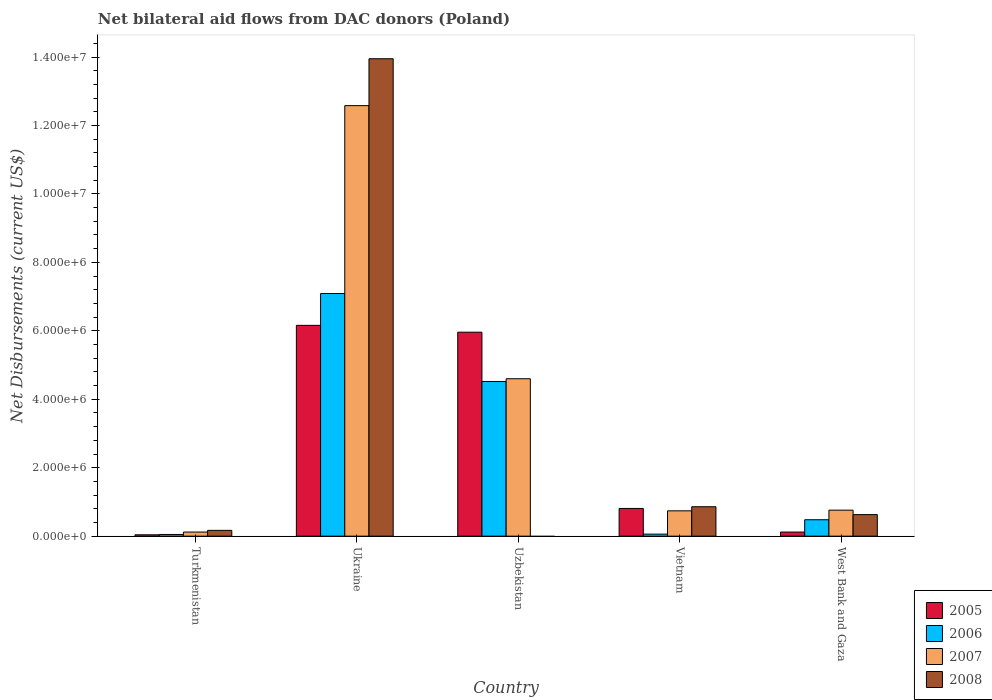How many groups of bars are there?
Your answer should be compact. 5. How many bars are there on the 4th tick from the left?
Offer a terse response. 4. What is the label of the 5th group of bars from the left?
Your response must be concise. West Bank and Gaza. What is the net bilateral aid flows in 2005 in Ukraine?
Provide a short and direct response. 6.16e+06. Across all countries, what is the maximum net bilateral aid flows in 2005?
Your answer should be compact. 6.16e+06. In which country was the net bilateral aid flows in 2006 maximum?
Ensure brevity in your answer.  Ukraine. What is the total net bilateral aid flows in 2008 in the graph?
Your response must be concise. 1.56e+07. What is the difference between the net bilateral aid flows in 2005 in Uzbekistan and that in West Bank and Gaza?
Your response must be concise. 5.84e+06. What is the difference between the net bilateral aid flows in 2008 in West Bank and Gaza and the net bilateral aid flows in 2006 in Turkmenistan?
Ensure brevity in your answer.  5.80e+05. What is the average net bilateral aid flows in 2008 per country?
Provide a succinct answer. 3.12e+06. What is the difference between the net bilateral aid flows of/in 2006 and net bilateral aid flows of/in 2005 in Uzbekistan?
Your answer should be very brief. -1.44e+06. What is the ratio of the net bilateral aid flows in 2005 in Ukraine to that in Uzbekistan?
Offer a terse response. 1.03. Is the difference between the net bilateral aid flows in 2006 in Ukraine and Vietnam greater than the difference between the net bilateral aid flows in 2005 in Ukraine and Vietnam?
Provide a short and direct response. Yes. What is the difference between the highest and the second highest net bilateral aid flows in 2008?
Ensure brevity in your answer.  1.31e+07. What is the difference between the highest and the lowest net bilateral aid flows in 2005?
Keep it short and to the point. 6.12e+06. In how many countries, is the net bilateral aid flows in 2005 greater than the average net bilateral aid flows in 2005 taken over all countries?
Provide a succinct answer. 2. How many bars are there?
Your answer should be very brief. 19. What is the difference between two consecutive major ticks on the Y-axis?
Make the answer very short. 2.00e+06. How are the legend labels stacked?
Your response must be concise. Vertical. What is the title of the graph?
Ensure brevity in your answer.  Net bilateral aid flows from DAC donors (Poland). What is the label or title of the Y-axis?
Offer a very short reply. Net Disbursements (current US$). What is the Net Disbursements (current US$) of 2005 in Turkmenistan?
Offer a terse response. 4.00e+04. What is the Net Disbursements (current US$) of 2006 in Turkmenistan?
Your answer should be very brief. 5.00e+04. What is the Net Disbursements (current US$) in 2007 in Turkmenistan?
Your answer should be compact. 1.20e+05. What is the Net Disbursements (current US$) in 2008 in Turkmenistan?
Offer a very short reply. 1.70e+05. What is the Net Disbursements (current US$) in 2005 in Ukraine?
Provide a succinct answer. 6.16e+06. What is the Net Disbursements (current US$) of 2006 in Ukraine?
Make the answer very short. 7.09e+06. What is the Net Disbursements (current US$) in 2007 in Ukraine?
Make the answer very short. 1.26e+07. What is the Net Disbursements (current US$) of 2008 in Ukraine?
Provide a succinct answer. 1.40e+07. What is the Net Disbursements (current US$) in 2005 in Uzbekistan?
Your answer should be compact. 5.96e+06. What is the Net Disbursements (current US$) in 2006 in Uzbekistan?
Provide a succinct answer. 4.52e+06. What is the Net Disbursements (current US$) in 2007 in Uzbekistan?
Your answer should be compact. 4.60e+06. What is the Net Disbursements (current US$) in 2005 in Vietnam?
Your response must be concise. 8.10e+05. What is the Net Disbursements (current US$) of 2007 in Vietnam?
Give a very brief answer. 7.40e+05. What is the Net Disbursements (current US$) of 2008 in Vietnam?
Provide a succinct answer. 8.60e+05. What is the Net Disbursements (current US$) in 2007 in West Bank and Gaza?
Offer a terse response. 7.60e+05. What is the Net Disbursements (current US$) of 2008 in West Bank and Gaza?
Your response must be concise. 6.30e+05. Across all countries, what is the maximum Net Disbursements (current US$) of 2005?
Give a very brief answer. 6.16e+06. Across all countries, what is the maximum Net Disbursements (current US$) of 2006?
Make the answer very short. 7.09e+06. Across all countries, what is the maximum Net Disbursements (current US$) in 2007?
Your answer should be very brief. 1.26e+07. Across all countries, what is the maximum Net Disbursements (current US$) in 2008?
Make the answer very short. 1.40e+07. Across all countries, what is the minimum Net Disbursements (current US$) of 2005?
Offer a very short reply. 4.00e+04. Across all countries, what is the minimum Net Disbursements (current US$) of 2006?
Provide a succinct answer. 5.00e+04. Across all countries, what is the minimum Net Disbursements (current US$) in 2007?
Offer a terse response. 1.20e+05. Across all countries, what is the minimum Net Disbursements (current US$) in 2008?
Your response must be concise. 0. What is the total Net Disbursements (current US$) in 2005 in the graph?
Ensure brevity in your answer.  1.31e+07. What is the total Net Disbursements (current US$) of 2006 in the graph?
Offer a terse response. 1.22e+07. What is the total Net Disbursements (current US$) in 2007 in the graph?
Your answer should be compact. 1.88e+07. What is the total Net Disbursements (current US$) in 2008 in the graph?
Your answer should be very brief. 1.56e+07. What is the difference between the Net Disbursements (current US$) in 2005 in Turkmenistan and that in Ukraine?
Give a very brief answer. -6.12e+06. What is the difference between the Net Disbursements (current US$) in 2006 in Turkmenistan and that in Ukraine?
Offer a terse response. -7.04e+06. What is the difference between the Net Disbursements (current US$) of 2007 in Turkmenistan and that in Ukraine?
Offer a very short reply. -1.25e+07. What is the difference between the Net Disbursements (current US$) in 2008 in Turkmenistan and that in Ukraine?
Ensure brevity in your answer.  -1.38e+07. What is the difference between the Net Disbursements (current US$) in 2005 in Turkmenistan and that in Uzbekistan?
Provide a short and direct response. -5.92e+06. What is the difference between the Net Disbursements (current US$) in 2006 in Turkmenistan and that in Uzbekistan?
Offer a terse response. -4.47e+06. What is the difference between the Net Disbursements (current US$) of 2007 in Turkmenistan and that in Uzbekistan?
Ensure brevity in your answer.  -4.48e+06. What is the difference between the Net Disbursements (current US$) of 2005 in Turkmenistan and that in Vietnam?
Offer a terse response. -7.70e+05. What is the difference between the Net Disbursements (current US$) of 2007 in Turkmenistan and that in Vietnam?
Provide a short and direct response. -6.20e+05. What is the difference between the Net Disbursements (current US$) of 2008 in Turkmenistan and that in Vietnam?
Give a very brief answer. -6.90e+05. What is the difference between the Net Disbursements (current US$) of 2006 in Turkmenistan and that in West Bank and Gaza?
Keep it short and to the point. -4.30e+05. What is the difference between the Net Disbursements (current US$) of 2007 in Turkmenistan and that in West Bank and Gaza?
Your answer should be compact. -6.40e+05. What is the difference between the Net Disbursements (current US$) of 2008 in Turkmenistan and that in West Bank and Gaza?
Your response must be concise. -4.60e+05. What is the difference between the Net Disbursements (current US$) in 2006 in Ukraine and that in Uzbekistan?
Give a very brief answer. 2.57e+06. What is the difference between the Net Disbursements (current US$) in 2007 in Ukraine and that in Uzbekistan?
Keep it short and to the point. 7.98e+06. What is the difference between the Net Disbursements (current US$) in 2005 in Ukraine and that in Vietnam?
Provide a short and direct response. 5.35e+06. What is the difference between the Net Disbursements (current US$) in 2006 in Ukraine and that in Vietnam?
Your answer should be compact. 7.03e+06. What is the difference between the Net Disbursements (current US$) in 2007 in Ukraine and that in Vietnam?
Give a very brief answer. 1.18e+07. What is the difference between the Net Disbursements (current US$) of 2008 in Ukraine and that in Vietnam?
Provide a short and direct response. 1.31e+07. What is the difference between the Net Disbursements (current US$) of 2005 in Ukraine and that in West Bank and Gaza?
Keep it short and to the point. 6.04e+06. What is the difference between the Net Disbursements (current US$) of 2006 in Ukraine and that in West Bank and Gaza?
Give a very brief answer. 6.61e+06. What is the difference between the Net Disbursements (current US$) of 2007 in Ukraine and that in West Bank and Gaza?
Offer a very short reply. 1.18e+07. What is the difference between the Net Disbursements (current US$) in 2008 in Ukraine and that in West Bank and Gaza?
Ensure brevity in your answer.  1.33e+07. What is the difference between the Net Disbursements (current US$) of 2005 in Uzbekistan and that in Vietnam?
Provide a succinct answer. 5.15e+06. What is the difference between the Net Disbursements (current US$) of 2006 in Uzbekistan and that in Vietnam?
Provide a short and direct response. 4.46e+06. What is the difference between the Net Disbursements (current US$) of 2007 in Uzbekistan and that in Vietnam?
Make the answer very short. 3.86e+06. What is the difference between the Net Disbursements (current US$) in 2005 in Uzbekistan and that in West Bank and Gaza?
Give a very brief answer. 5.84e+06. What is the difference between the Net Disbursements (current US$) in 2006 in Uzbekistan and that in West Bank and Gaza?
Make the answer very short. 4.04e+06. What is the difference between the Net Disbursements (current US$) in 2007 in Uzbekistan and that in West Bank and Gaza?
Offer a terse response. 3.84e+06. What is the difference between the Net Disbursements (current US$) of 2005 in Vietnam and that in West Bank and Gaza?
Ensure brevity in your answer.  6.90e+05. What is the difference between the Net Disbursements (current US$) in 2006 in Vietnam and that in West Bank and Gaza?
Provide a short and direct response. -4.20e+05. What is the difference between the Net Disbursements (current US$) of 2007 in Vietnam and that in West Bank and Gaza?
Your answer should be compact. -2.00e+04. What is the difference between the Net Disbursements (current US$) of 2008 in Vietnam and that in West Bank and Gaza?
Your answer should be very brief. 2.30e+05. What is the difference between the Net Disbursements (current US$) in 2005 in Turkmenistan and the Net Disbursements (current US$) in 2006 in Ukraine?
Your response must be concise. -7.05e+06. What is the difference between the Net Disbursements (current US$) in 2005 in Turkmenistan and the Net Disbursements (current US$) in 2007 in Ukraine?
Keep it short and to the point. -1.25e+07. What is the difference between the Net Disbursements (current US$) of 2005 in Turkmenistan and the Net Disbursements (current US$) of 2008 in Ukraine?
Offer a terse response. -1.39e+07. What is the difference between the Net Disbursements (current US$) of 2006 in Turkmenistan and the Net Disbursements (current US$) of 2007 in Ukraine?
Provide a succinct answer. -1.25e+07. What is the difference between the Net Disbursements (current US$) in 2006 in Turkmenistan and the Net Disbursements (current US$) in 2008 in Ukraine?
Offer a very short reply. -1.39e+07. What is the difference between the Net Disbursements (current US$) in 2007 in Turkmenistan and the Net Disbursements (current US$) in 2008 in Ukraine?
Ensure brevity in your answer.  -1.38e+07. What is the difference between the Net Disbursements (current US$) in 2005 in Turkmenistan and the Net Disbursements (current US$) in 2006 in Uzbekistan?
Make the answer very short. -4.48e+06. What is the difference between the Net Disbursements (current US$) in 2005 in Turkmenistan and the Net Disbursements (current US$) in 2007 in Uzbekistan?
Your answer should be compact. -4.56e+06. What is the difference between the Net Disbursements (current US$) in 2006 in Turkmenistan and the Net Disbursements (current US$) in 2007 in Uzbekistan?
Provide a short and direct response. -4.55e+06. What is the difference between the Net Disbursements (current US$) in 2005 in Turkmenistan and the Net Disbursements (current US$) in 2006 in Vietnam?
Give a very brief answer. -2.00e+04. What is the difference between the Net Disbursements (current US$) in 2005 in Turkmenistan and the Net Disbursements (current US$) in 2007 in Vietnam?
Your answer should be very brief. -7.00e+05. What is the difference between the Net Disbursements (current US$) of 2005 in Turkmenistan and the Net Disbursements (current US$) of 2008 in Vietnam?
Offer a terse response. -8.20e+05. What is the difference between the Net Disbursements (current US$) in 2006 in Turkmenistan and the Net Disbursements (current US$) in 2007 in Vietnam?
Give a very brief answer. -6.90e+05. What is the difference between the Net Disbursements (current US$) in 2006 in Turkmenistan and the Net Disbursements (current US$) in 2008 in Vietnam?
Ensure brevity in your answer.  -8.10e+05. What is the difference between the Net Disbursements (current US$) of 2007 in Turkmenistan and the Net Disbursements (current US$) of 2008 in Vietnam?
Offer a very short reply. -7.40e+05. What is the difference between the Net Disbursements (current US$) in 2005 in Turkmenistan and the Net Disbursements (current US$) in 2006 in West Bank and Gaza?
Provide a short and direct response. -4.40e+05. What is the difference between the Net Disbursements (current US$) of 2005 in Turkmenistan and the Net Disbursements (current US$) of 2007 in West Bank and Gaza?
Give a very brief answer. -7.20e+05. What is the difference between the Net Disbursements (current US$) of 2005 in Turkmenistan and the Net Disbursements (current US$) of 2008 in West Bank and Gaza?
Offer a very short reply. -5.90e+05. What is the difference between the Net Disbursements (current US$) in 2006 in Turkmenistan and the Net Disbursements (current US$) in 2007 in West Bank and Gaza?
Make the answer very short. -7.10e+05. What is the difference between the Net Disbursements (current US$) of 2006 in Turkmenistan and the Net Disbursements (current US$) of 2008 in West Bank and Gaza?
Give a very brief answer. -5.80e+05. What is the difference between the Net Disbursements (current US$) of 2007 in Turkmenistan and the Net Disbursements (current US$) of 2008 in West Bank and Gaza?
Ensure brevity in your answer.  -5.10e+05. What is the difference between the Net Disbursements (current US$) in 2005 in Ukraine and the Net Disbursements (current US$) in 2006 in Uzbekistan?
Make the answer very short. 1.64e+06. What is the difference between the Net Disbursements (current US$) of 2005 in Ukraine and the Net Disbursements (current US$) of 2007 in Uzbekistan?
Give a very brief answer. 1.56e+06. What is the difference between the Net Disbursements (current US$) of 2006 in Ukraine and the Net Disbursements (current US$) of 2007 in Uzbekistan?
Make the answer very short. 2.49e+06. What is the difference between the Net Disbursements (current US$) of 2005 in Ukraine and the Net Disbursements (current US$) of 2006 in Vietnam?
Your answer should be compact. 6.10e+06. What is the difference between the Net Disbursements (current US$) of 2005 in Ukraine and the Net Disbursements (current US$) of 2007 in Vietnam?
Offer a terse response. 5.42e+06. What is the difference between the Net Disbursements (current US$) of 2005 in Ukraine and the Net Disbursements (current US$) of 2008 in Vietnam?
Your answer should be very brief. 5.30e+06. What is the difference between the Net Disbursements (current US$) of 2006 in Ukraine and the Net Disbursements (current US$) of 2007 in Vietnam?
Provide a succinct answer. 6.35e+06. What is the difference between the Net Disbursements (current US$) in 2006 in Ukraine and the Net Disbursements (current US$) in 2008 in Vietnam?
Give a very brief answer. 6.23e+06. What is the difference between the Net Disbursements (current US$) in 2007 in Ukraine and the Net Disbursements (current US$) in 2008 in Vietnam?
Your answer should be very brief. 1.17e+07. What is the difference between the Net Disbursements (current US$) of 2005 in Ukraine and the Net Disbursements (current US$) of 2006 in West Bank and Gaza?
Ensure brevity in your answer.  5.68e+06. What is the difference between the Net Disbursements (current US$) of 2005 in Ukraine and the Net Disbursements (current US$) of 2007 in West Bank and Gaza?
Your response must be concise. 5.40e+06. What is the difference between the Net Disbursements (current US$) in 2005 in Ukraine and the Net Disbursements (current US$) in 2008 in West Bank and Gaza?
Offer a very short reply. 5.53e+06. What is the difference between the Net Disbursements (current US$) in 2006 in Ukraine and the Net Disbursements (current US$) in 2007 in West Bank and Gaza?
Your answer should be compact. 6.33e+06. What is the difference between the Net Disbursements (current US$) of 2006 in Ukraine and the Net Disbursements (current US$) of 2008 in West Bank and Gaza?
Give a very brief answer. 6.46e+06. What is the difference between the Net Disbursements (current US$) in 2007 in Ukraine and the Net Disbursements (current US$) in 2008 in West Bank and Gaza?
Keep it short and to the point. 1.20e+07. What is the difference between the Net Disbursements (current US$) in 2005 in Uzbekistan and the Net Disbursements (current US$) in 2006 in Vietnam?
Your answer should be compact. 5.90e+06. What is the difference between the Net Disbursements (current US$) in 2005 in Uzbekistan and the Net Disbursements (current US$) in 2007 in Vietnam?
Your response must be concise. 5.22e+06. What is the difference between the Net Disbursements (current US$) of 2005 in Uzbekistan and the Net Disbursements (current US$) of 2008 in Vietnam?
Keep it short and to the point. 5.10e+06. What is the difference between the Net Disbursements (current US$) in 2006 in Uzbekistan and the Net Disbursements (current US$) in 2007 in Vietnam?
Your answer should be very brief. 3.78e+06. What is the difference between the Net Disbursements (current US$) of 2006 in Uzbekistan and the Net Disbursements (current US$) of 2008 in Vietnam?
Offer a very short reply. 3.66e+06. What is the difference between the Net Disbursements (current US$) of 2007 in Uzbekistan and the Net Disbursements (current US$) of 2008 in Vietnam?
Your response must be concise. 3.74e+06. What is the difference between the Net Disbursements (current US$) in 2005 in Uzbekistan and the Net Disbursements (current US$) in 2006 in West Bank and Gaza?
Your answer should be compact. 5.48e+06. What is the difference between the Net Disbursements (current US$) of 2005 in Uzbekistan and the Net Disbursements (current US$) of 2007 in West Bank and Gaza?
Your answer should be very brief. 5.20e+06. What is the difference between the Net Disbursements (current US$) of 2005 in Uzbekistan and the Net Disbursements (current US$) of 2008 in West Bank and Gaza?
Your answer should be very brief. 5.33e+06. What is the difference between the Net Disbursements (current US$) in 2006 in Uzbekistan and the Net Disbursements (current US$) in 2007 in West Bank and Gaza?
Offer a terse response. 3.76e+06. What is the difference between the Net Disbursements (current US$) of 2006 in Uzbekistan and the Net Disbursements (current US$) of 2008 in West Bank and Gaza?
Provide a succinct answer. 3.89e+06. What is the difference between the Net Disbursements (current US$) of 2007 in Uzbekistan and the Net Disbursements (current US$) of 2008 in West Bank and Gaza?
Keep it short and to the point. 3.97e+06. What is the difference between the Net Disbursements (current US$) of 2005 in Vietnam and the Net Disbursements (current US$) of 2007 in West Bank and Gaza?
Your answer should be very brief. 5.00e+04. What is the difference between the Net Disbursements (current US$) of 2006 in Vietnam and the Net Disbursements (current US$) of 2007 in West Bank and Gaza?
Offer a terse response. -7.00e+05. What is the difference between the Net Disbursements (current US$) in 2006 in Vietnam and the Net Disbursements (current US$) in 2008 in West Bank and Gaza?
Offer a terse response. -5.70e+05. What is the difference between the Net Disbursements (current US$) in 2007 in Vietnam and the Net Disbursements (current US$) in 2008 in West Bank and Gaza?
Give a very brief answer. 1.10e+05. What is the average Net Disbursements (current US$) of 2005 per country?
Your answer should be compact. 2.62e+06. What is the average Net Disbursements (current US$) of 2006 per country?
Provide a succinct answer. 2.44e+06. What is the average Net Disbursements (current US$) in 2007 per country?
Offer a terse response. 3.76e+06. What is the average Net Disbursements (current US$) in 2008 per country?
Offer a very short reply. 3.12e+06. What is the difference between the Net Disbursements (current US$) in 2005 and Net Disbursements (current US$) in 2006 in Turkmenistan?
Offer a terse response. -10000. What is the difference between the Net Disbursements (current US$) in 2005 and Net Disbursements (current US$) in 2008 in Turkmenistan?
Your answer should be compact. -1.30e+05. What is the difference between the Net Disbursements (current US$) of 2006 and Net Disbursements (current US$) of 2007 in Turkmenistan?
Provide a succinct answer. -7.00e+04. What is the difference between the Net Disbursements (current US$) of 2006 and Net Disbursements (current US$) of 2008 in Turkmenistan?
Keep it short and to the point. -1.20e+05. What is the difference between the Net Disbursements (current US$) of 2005 and Net Disbursements (current US$) of 2006 in Ukraine?
Provide a short and direct response. -9.30e+05. What is the difference between the Net Disbursements (current US$) of 2005 and Net Disbursements (current US$) of 2007 in Ukraine?
Offer a very short reply. -6.42e+06. What is the difference between the Net Disbursements (current US$) in 2005 and Net Disbursements (current US$) in 2008 in Ukraine?
Offer a terse response. -7.79e+06. What is the difference between the Net Disbursements (current US$) in 2006 and Net Disbursements (current US$) in 2007 in Ukraine?
Keep it short and to the point. -5.49e+06. What is the difference between the Net Disbursements (current US$) of 2006 and Net Disbursements (current US$) of 2008 in Ukraine?
Make the answer very short. -6.86e+06. What is the difference between the Net Disbursements (current US$) of 2007 and Net Disbursements (current US$) of 2008 in Ukraine?
Make the answer very short. -1.37e+06. What is the difference between the Net Disbursements (current US$) of 2005 and Net Disbursements (current US$) of 2006 in Uzbekistan?
Offer a terse response. 1.44e+06. What is the difference between the Net Disbursements (current US$) in 2005 and Net Disbursements (current US$) in 2007 in Uzbekistan?
Make the answer very short. 1.36e+06. What is the difference between the Net Disbursements (current US$) of 2005 and Net Disbursements (current US$) of 2006 in Vietnam?
Offer a very short reply. 7.50e+05. What is the difference between the Net Disbursements (current US$) of 2005 and Net Disbursements (current US$) of 2007 in Vietnam?
Provide a short and direct response. 7.00e+04. What is the difference between the Net Disbursements (current US$) of 2005 and Net Disbursements (current US$) of 2008 in Vietnam?
Offer a terse response. -5.00e+04. What is the difference between the Net Disbursements (current US$) in 2006 and Net Disbursements (current US$) in 2007 in Vietnam?
Offer a terse response. -6.80e+05. What is the difference between the Net Disbursements (current US$) of 2006 and Net Disbursements (current US$) of 2008 in Vietnam?
Make the answer very short. -8.00e+05. What is the difference between the Net Disbursements (current US$) in 2007 and Net Disbursements (current US$) in 2008 in Vietnam?
Ensure brevity in your answer.  -1.20e+05. What is the difference between the Net Disbursements (current US$) in 2005 and Net Disbursements (current US$) in 2006 in West Bank and Gaza?
Make the answer very short. -3.60e+05. What is the difference between the Net Disbursements (current US$) in 2005 and Net Disbursements (current US$) in 2007 in West Bank and Gaza?
Keep it short and to the point. -6.40e+05. What is the difference between the Net Disbursements (current US$) of 2005 and Net Disbursements (current US$) of 2008 in West Bank and Gaza?
Your response must be concise. -5.10e+05. What is the difference between the Net Disbursements (current US$) in 2006 and Net Disbursements (current US$) in 2007 in West Bank and Gaza?
Offer a terse response. -2.80e+05. What is the difference between the Net Disbursements (current US$) of 2006 and Net Disbursements (current US$) of 2008 in West Bank and Gaza?
Provide a short and direct response. -1.50e+05. What is the ratio of the Net Disbursements (current US$) of 2005 in Turkmenistan to that in Ukraine?
Make the answer very short. 0.01. What is the ratio of the Net Disbursements (current US$) of 2006 in Turkmenistan to that in Ukraine?
Your answer should be compact. 0.01. What is the ratio of the Net Disbursements (current US$) in 2007 in Turkmenistan to that in Ukraine?
Offer a terse response. 0.01. What is the ratio of the Net Disbursements (current US$) in 2008 in Turkmenistan to that in Ukraine?
Your response must be concise. 0.01. What is the ratio of the Net Disbursements (current US$) of 2005 in Turkmenistan to that in Uzbekistan?
Offer a very short reply. 0.01. What is the ratio of the Net Disbursements (current US$) in 2006 in Turkmenistan to that in Uzbekistan?
Make the answer very short. 0.01. What is the ratio of the Net Disbursements (current US$) of 2007 in Turkmenistan to that in Uzbekistan?
Make the answer very short. 0.03. What is the ratio of the Net Disbursements (current US$) in 2005 in Turkmenistan to that in Vietnam?
Offer a terse response. 0.05. What is the ratio of the Net Disbursements (current US$) in 2007 in Turkmenistan to that in Vietnam?
Ensure brevity in your answer.  0.16. What is the ratio of the Net Disbursements (current US$) in 2008 in Turkmenistan to that in Vietnam?
Your response must be concise. 0.2. What is the ratio of the Net Disbursements (current US$) of 2006 in Turkmenistan to that in West Bank and Gaza?
Your response must be concise. 0.1. What is the ratio of the Net Disbursements (current US$) of 2007 in Turkmenistan to that in West Bank and Gaza?
Ensure brevity in your answer.  0.16. What is the ratio of the Net Disbursements (current US$) in 2008 in Turkmenistan to that in West Bank and Gaza?
Your answer should be very brief. 0.27. What is the ratio of the Net Disbursements (current US$) in 2005 in Ukraine to that in Uzbekistan?
Your answer should be compact. 1.03. What is the ratio of the Net Disbursements (current US$) in 2006 in Ukraine to that in Uzbekistan?
Ensure brevity in your answer.  1.57. What is the ratio of the Net Disbursements (current US$) of 2007 in Ukraine to that in Uzbekistan?
Give a very brief answer. 2.73. What is the ratio of the Net Disbursements (current US$) in 2005 in Ukraine to that in Vietnam?
Offer a very short reply. 7.6. What is the ratio of the Net Disbursements (current US$) of 2006 in Ukraine to that in Vietnam?
Provide a short and direct response. 118.17. What is the ratio of the Net Disbursements (current US$) in 2008 in Ukraine to that in Vietnam?
Your answer should be very brief. 16.22. What is the ratio of the Net Disbursements (current US$) of 2005 in Ukraine to that in West Bank and Gaza?
Give a very brief answer. 51.33. What is the ratio of the Net Disbursements (current US$) in 2006 in Ukraine to that in West Bank and Gaza?
Your response must be concise. 14.77. What is the ratio of the Net Disbursements (current US$) in 2007 in Ukraine to that in West Bank and Gaza?
Provide a succinct answer. 16.55. What is the ratio of the Net Disbursements (current US$) in 2008 in Ukraine to that in West Bank and Gaza?
Provide a short and direct response. 22.14. What is the ratio of the Net Disbursements (current US$) in 2005 in Uzbekistan to that in Vietnam?
Offer a terse response. 7.36. What is the ratio of the Net Disbursements (current US$) in 2006 in Uzbekistan to that in Vietnam?
Keep it short and to the point. 75.33. What is the ratio of the Net Disbursements (current US$) in 2007 in Uzbekistan to that in Vietnam?
Your answer should be very brief. 6.22. What is the ratio of the Net Disbursements (current US$) in 2005 in Uzbekistan to that in West Bank and Gaza?
Give a very brief answer. 49.67. What is the ratio of the Net Disbursements (current US$) of 2006 in Uzbekistan to that in West Bank and Gaza?
Give a very brief answer. 9.42. What is the ratio of the Net Disbursements (current US$) in 2007 in Uzbekistan to that in West Bank and Gaza?
Provide a succinct answer. 6.05. What is the ratio of the Net Disbursements (current US$) of 2005 in Vietnam to that in West Bank and Gaza?
Offer a very short reply. 6.75. What is the ratio of the Net Disbursements (current US$) in 2006 in Vietnam to that in West Bank and Gaza?
Your answer should be very brief. 0.12. What is the ratio of the Net Disbursements (current US$) of 2007 in Vietnam to that in West Bank and Gaza?
Give a very brief answer. 0.97. What is the ratio of the Net Disbursements (current US$) in 2008 in Vietnam to that in West Bank and Gaza?
Provide a succinct answer. 1.37. What is the difference between the highest and the second highest Net Disbursements (current US$) in 2006?
Provide a succinct answer. 2.57e+06. What is the difference between the highest and the second highest Net Disbursements (current US$) of 2007?
Your response must be concise. 7.98e+06. What is the difference between the highest and the second highest Net Disbursements (current US$) of 2008?
Keep it short and to the point. 1.31e+07. What is the difference between the highest and the lowest Net Disbursements (current US$) in 2005?
Offer a very short reply. 6.12e+06. What is the difference between the highest and the lowest Net Disbursements (current US$) of 2006?
Your answer should be very brief. 7.04e+06. What is the difference between the highest and the lowest Net Disbursements (current US$) in 2007?
Give a very brief answer. 1.25e+07. What is the difference between the highest and the lowest Net Disbursements (current US$) in 2008?
Make the answer very short. 1.40e+07. 